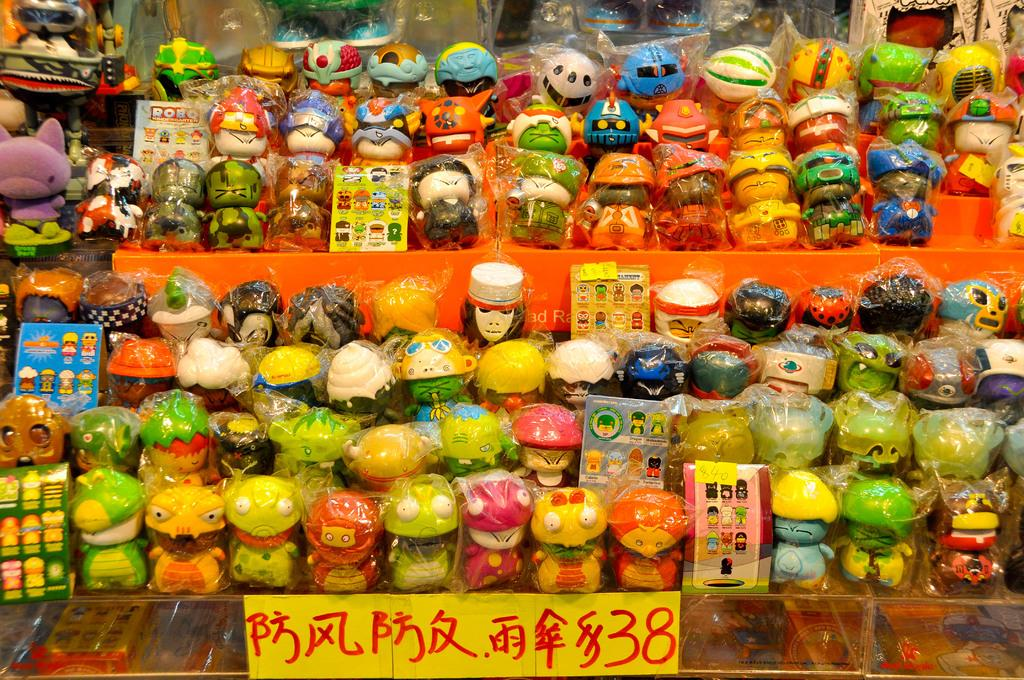Provide a one-sentence caption for the provided image. A display of items for sale, that are selling for a denomination of 38. 